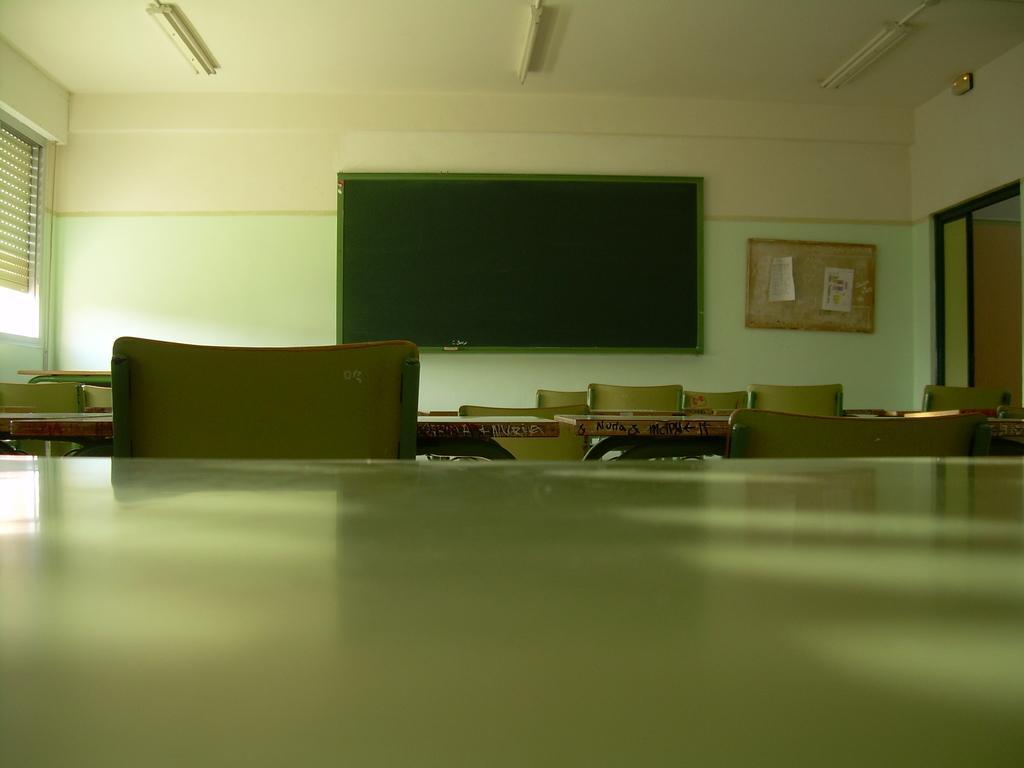Please provide a concise description of this image. Here we can see tables, chairs, boards, and posters. In the background we can see a wall. 